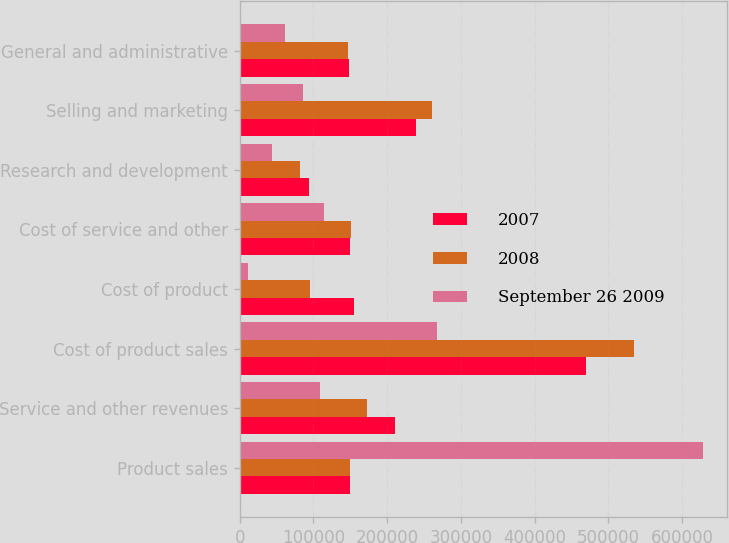Convert chart. <chart><loc_0><loc_0><loc_500><loc_500><stacked_bar_chart><ecel><fcel>Product sales<fcel>Service and other revenues<fcel>Cost of product sales<fcel>Cost of product<fcel>Cost of service and other<fcel>Research and development<fcel>Selling and marketing<fcel>General and administrative<nl><fcel>2007<fcel>149297<fcel>210148<fcel>470295<fcel>155519<fcel>149769<fcel>94328<fcel>238977<fcel>148825<nl><fcel>2008<fcel>149297<fcel>172052<fcel>535082<fcel>95310<fcel>151589<fcel>81421<fcel>261524<fcel>147405<nl><fcel>September 26 2009<fcel>628854<fcel>109514<fcel>267470<fcel>11262<fcel>114307<fcel>44381<fcel>85520<fcel>62092<nl></chart> 